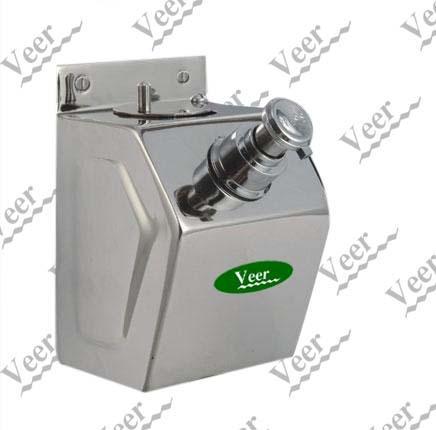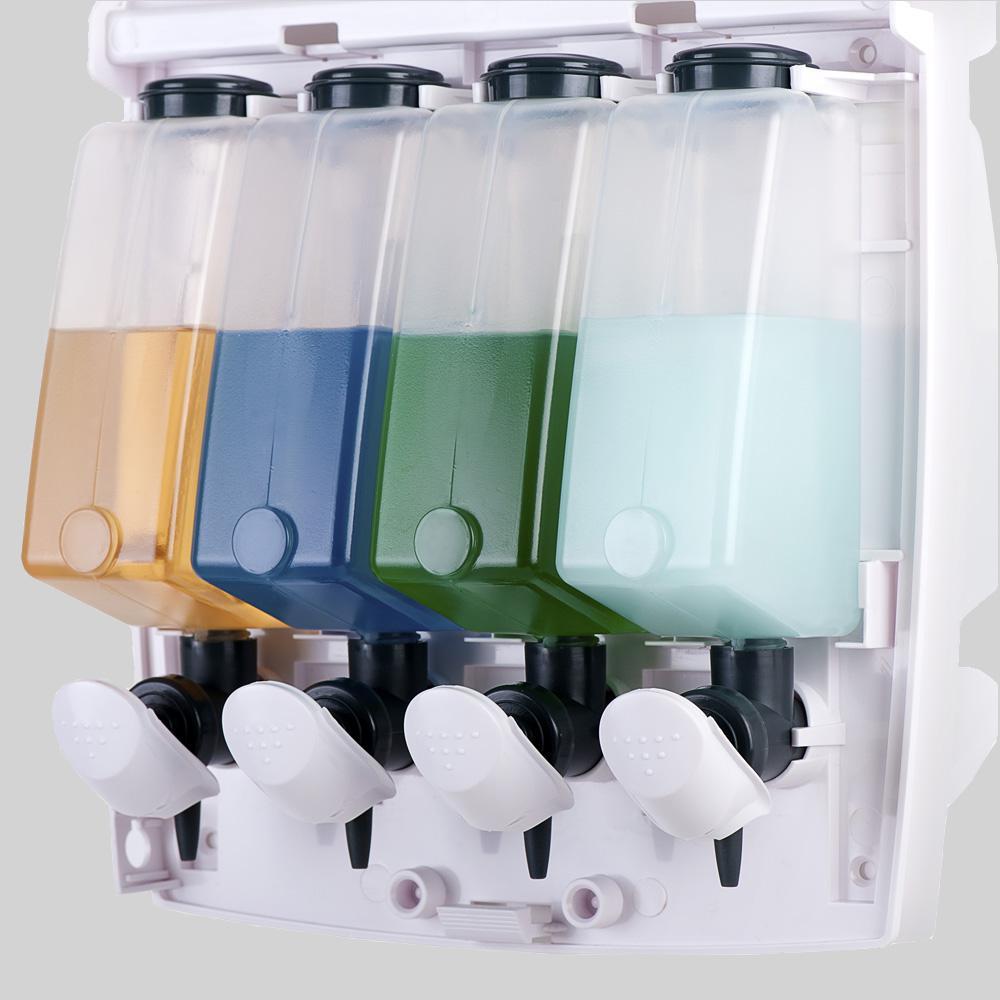The first image is the image on the left, the second image is the image on the right. Considering the images on both sides, is "An image shows exactly three side-by-side dispensers." valid? Answer yes or no. No. The first image is the image on the left, the second image is the image on the right. Given the left and right images, does the statement "1 of the images has 3 dispensers lined up in a row." hold true? Answer yes or no. No. 